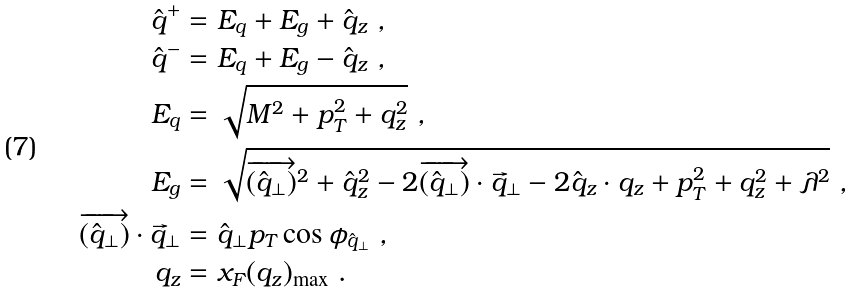Convert formula to latex. <formula><loc_0><loc_0><loc_500><loc_500>\hat { q } ^ { + } & = E _ { q } + E _ { g } + \hat { q } _ { z } \ , \\ \hat { q } ^ { - } & = E _ { q } + E _ { g } - \hat { q } _ { z } \ , \\ E _ { q } & = \sqrt { M ^ { 2 } + p _ { T } ^ { 2 } + q _ { z } ^ { 2 } } \ , \\ E _ { g } & = \sqrt { \overrightarrow { ( \hat { q } _ { \perp } ) } ^ { 2 } + \hat { q } _ { z } ^ { 2 } - 2 \overrightarrow { ( \hat { q } _ { \perp } ) } \cdot \vec { q } _ { \perp } - 2 \hat { q } _ { z } \cdot q _ { z } + p _ { T } ^ { 2 } + q _ { z } ^ { 2 } + \lambda ^ { 2 } } \ , \\ \overrightarrow { ( \hat { q } _ { \perp } ) } \cdot \vec { q } _ { \perp } & = \hat { q } _ { \perp } p _ { T } \cos \phi _ { \hat { q } _ { \perp } } \ , \\ q _ { z } & = x _ { F } ( q _ { z } ) _ { \max } \ .</formula> 